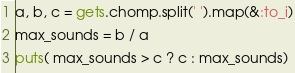<code> <loc_0><loc_0><loc_500><loc_500><_Ruby_>a, b, c = gets.chomp.split(' ').map(&:to_i)
max_sounds = b / a
puts( max_sounds > c ? c : max_sounds)</code> 